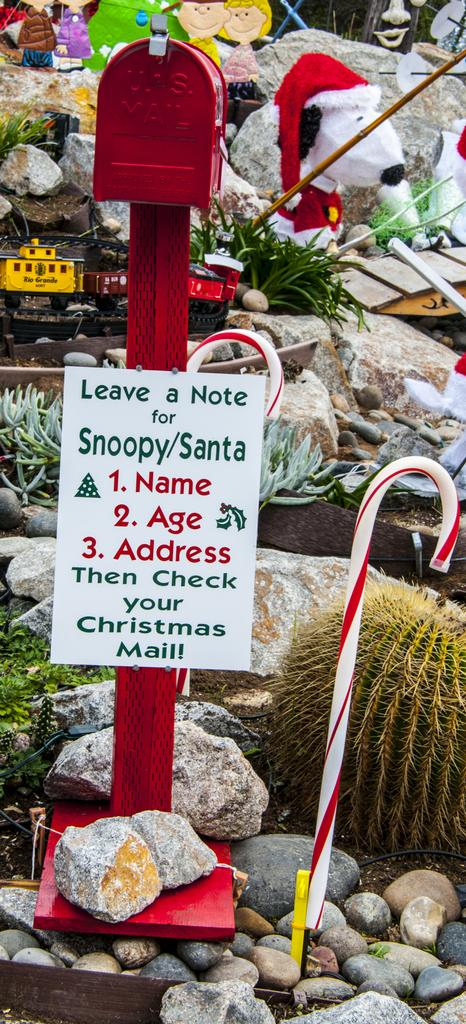What type of natural elements can be seen in the image? There are stones and plants in the image. What man-made objects are present? There are sticks, a poster, and toys in the image. Are there any unidentified objects in the image? Yes, there are some unspecified objects in the image. Can you tell me what request the aunt made in the image? There is no mention of an aunt or any request in the image. Where is the bucket located in the image? There is no bucket present in the image. 